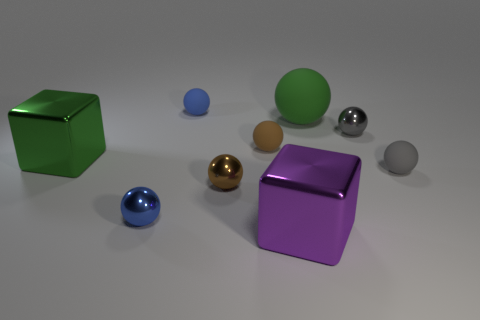Subtract 2 spheres. How many spheres are left? 5 Subtract all brown spheres. How many spheres are left? 5 Subtract all tiny shiny spheres. How many spheres are left? 4 Subtract all purple spheres. Subtract all brown cylinders. How many spheres are left? 7 Add 1 small brown matte balls. How many objects exist? 10 Subtract all cubes. How many objects are left? 7 Subtract all balls. Subtract all green spheres. How many objects are left? 1 Add 3 purple cubes. How many purple cubes are left? 4 Add 1 tiny gray matte cylinders. How many tiny gray matte cylinders exist? 1 Subtract 0 brown cylinders. How many objects are left? 9 